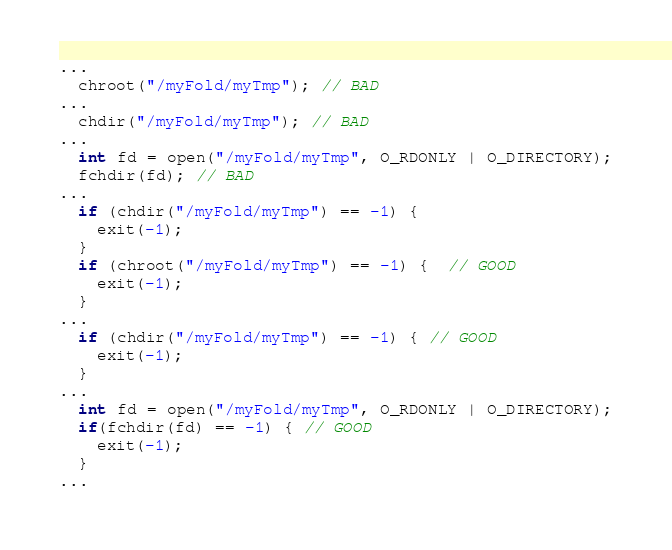Convert code to text. <code><loc_0><loc_0><loc_500><loc_500><_C++_>...
  chroot("/myFold/myTmp"); // BAD
...
  chdir("/myFold/myTmp"); // BAD
...
  int fd = open("/myFold/myTmp", O_RDONLY | O_DIRECTORY);
  fchdir(fd); // BAD
...
  if (chdir("/myFold/myTmp") == -1) {
    exit(-1);
  }
  if (chroot("/myFold/myTmp") == -1) {  // GOOD
    exit(-1);
  }
...
  if (chdir("/myFold/myTmp") == -1) { // GOOD
    exit(-1);
  }
...
  int fd = open("/myFold/myTmp", O_RDONLY | O_DIRECTORY);
  if(fchdir(fd) == -1) { // GOOD
    exit(-1);
  }
...
</code> 